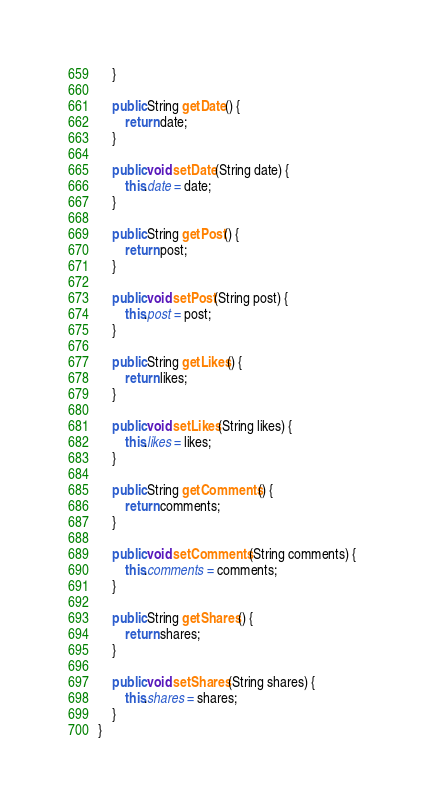<code> <loc_0><loc_0><loc_500><loc_500><_Java_>    }

    public String getDate() {
        return date;
    }

    public void setDate(String date) {
        this.date = date;
    }

    public String getPost() {
        return post;
    }

    public void setPost(String post) {
        this.post = post;
    }

    public String getLikes() {
        return likes;
    }

    public void setLikes(String likes) {
        this.likes = likes;
    }

    public String getComments() {
        return comments;
    }

    public void setComments(String comments) {
        this.comments = comments;
    }

    public String getShares() {
        return shares;
    }

    public void setShares(String shares) {
        this.shares = shares;
    }
}</code> 